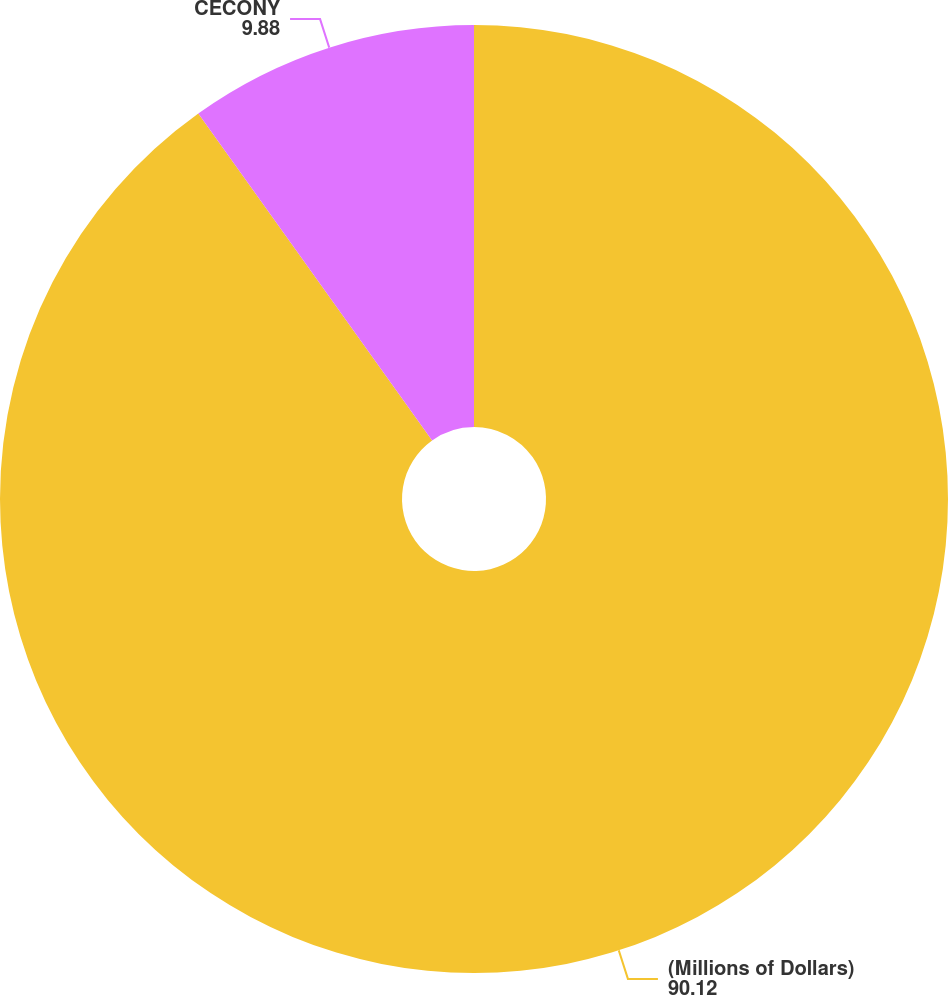<chart> <loc_0><loc_0><loc_500><loc_500><pie_chart><fcel>(Millions of Dollars)<fcel>CECONY<nl><fcel>90.12%<fcel>9.88%<nl></chart> 